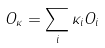<formula> <loc_0><loc_0><loc_500><loc_500>O _ { \kappa } = \sum _ { i } \kappa _ { i } O _ { i }</formula> 